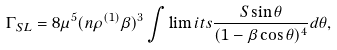<formula> <loc_0><loc_0><loc_500><loc_500>\Gamma _ { S L } = 8 \mu ^ { 5 } ( n \rho ^ { ( 1 ) } \beta ) ^ { 3 } \int \lim i t s \frac { S \sin \theta } { ( 1 - \beta \cos \theta ) ^ { 4 } } d \theta ,</formula> 